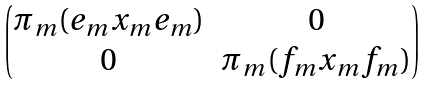Convert formula to latex. <formula><loc_0><loc_0><loc_500><loc_500>\begin{pmatrix} \pi _ { m } ( e _ { m } x _ { m } e _ { m } ) & 0 \\ 0 & \pi _ { m } ( f _ { m } x _ { m } f _ { m } ) \end{pmatrix}</formula> 